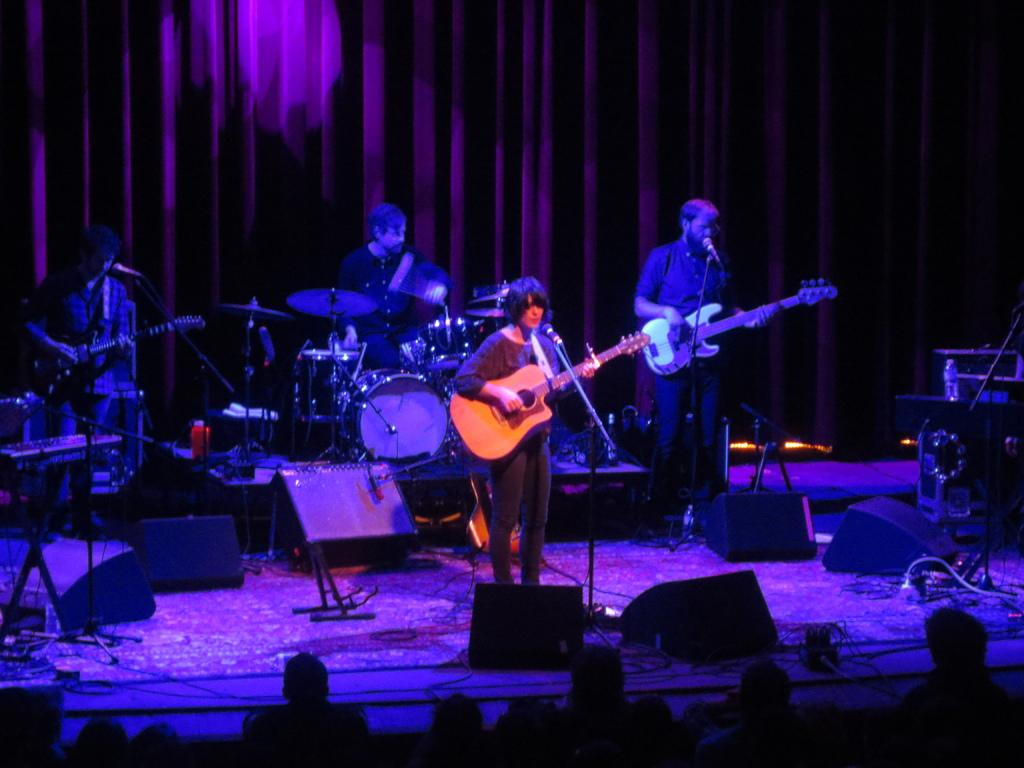What are the persons in the image doing? The persons in the image are playing musical instruments. What object resembles a speaker in the image? There is an object that looks like a speaker in the image. Can you describe the crowd present in the image? Yes, there is a crowd present in the image. What type of canvas is being used by the persons playing musical instruments in the image? There is no canvas present in the image; the persons are playing musical instruments without any canvas. What apparatus is being used by the crowd to listen to the music in the image? There is no specific apparatus mentioned or visible in the image for the crowd to listen to the music; they are simply present in the scene. 